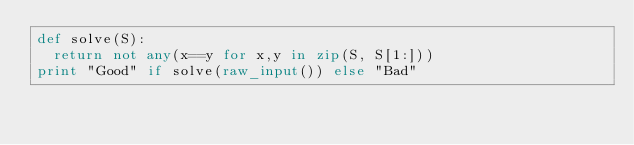Convert code to text. <code><loc_0><loc_0><loc_500><loc_500><_Python_>def solve(S):
  return not any(x==y for x,y in zip(S, S[1:]))
print "Good" if solve(raw_input()) else "Bad"</code> 